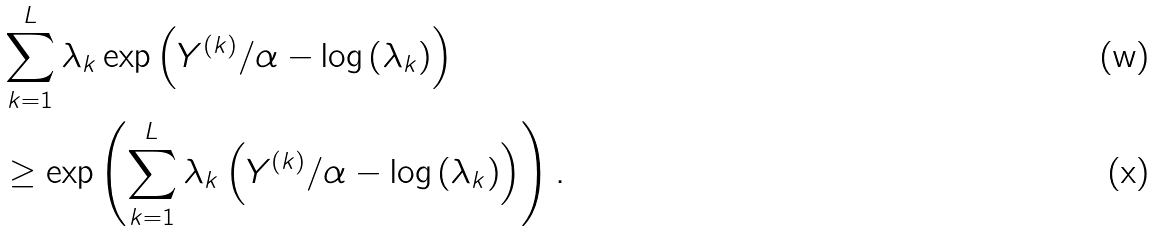<formula> <loc_0><loc_0><loc_500><loc_500>& \sum _ { k = 1 } ^ { L } { \lambda _ { k } \exp \left ( Y ^ { ( k ) } / \alpha - \log \left ( \lambda _ { k } \right ) \right ) } \\ & \geq \exp \left ( \sum _ { k = 1 } ^ { L } { \lambda _ { k } \left ( Y ^ { ( k ) } / \alpha - \log \left ( \lambda _ { k } \right ) \right ) } \right ) .</formula> 